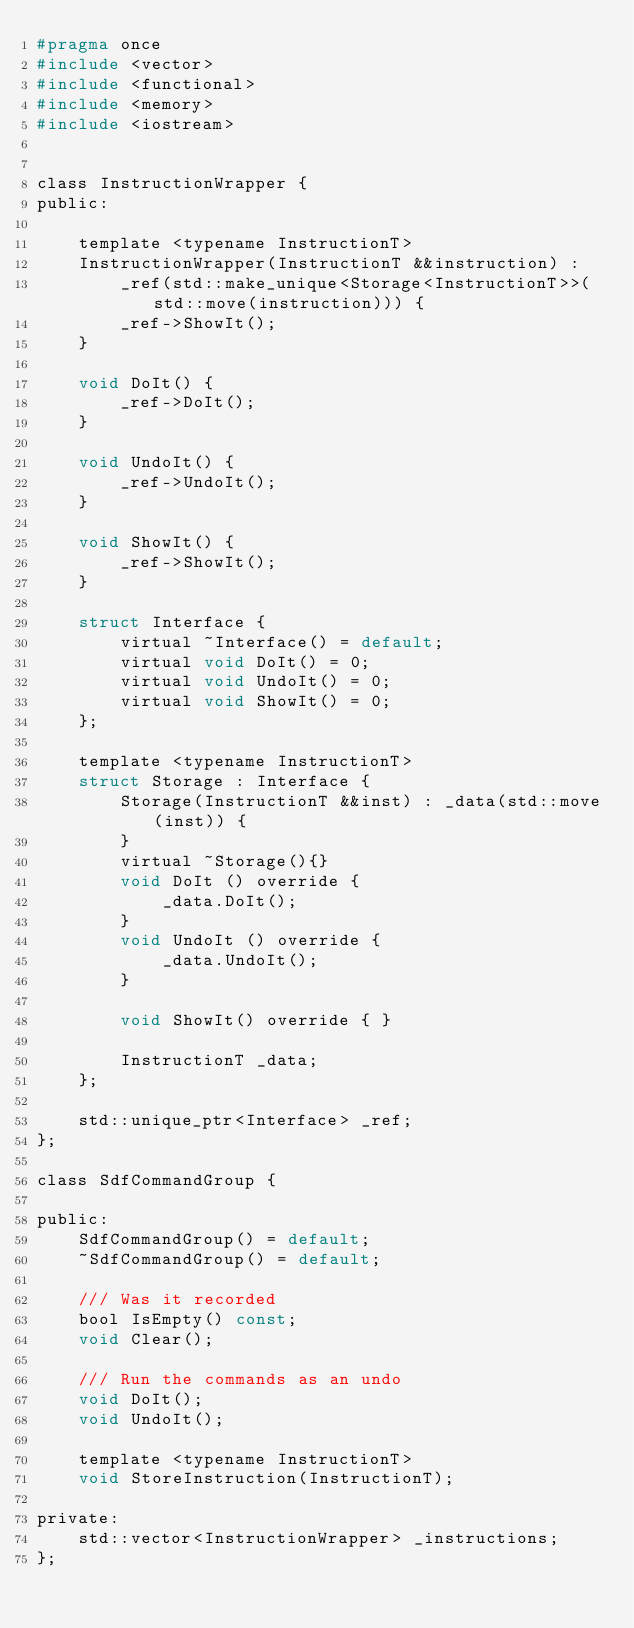<code> <loc_0><loc_0><loc_500><loc_500><_C_>#pragma once
#include <vector>
#include <functional>
#include <memory>
#include <iostream>


class InstructionWrapper {
public:

    template <typename InstructionT>
    InstructionWrapper(InstructionT &&instruction) :
        _ref(std::make_unique<Storage<InstructionT>>(std::move(instruction))) {
        _ref->ShowIt();
    }

    void DoIt() {
        _ref->DoIt();
    }

    void UndoIt() {
        _ref->UndoIt();
    }

    void ShowIt() {
        _ref->ShowIt();
    }

    struct Interface {
        virtual ~Interface() = default;
        virtual void DoIt() = 0;
        virtual void UndoIt() = 0;
        virtual void ShowIt() = 0;
    };

    template <typename InstructionT>
    struct Storage : Interface {
        Storage(InstructionT &&inst) : _data(std::move(inst)) {
        }
        virtual ~Storage(){}
        void DoIt () override {
            _data.DoIt();
        }
        void UndoIt () override {
            _data.UndoIt();
        }

        void ShowIt() override { }

        InstructionT _data;
    };

    std::unique_ptr<Interface> _ref;
};

class SdfCommandGroup {

public:
    SdfCommandGroup() = default;
    ~SdfCommandGroup() = default;

    /// Was it recorded
    bool IsEmpty() const;
    void Clear();

    /// Run the commands as an undo
    void DoIt();
    void UndoIt();

    template <typename InstructionT>
    void StoreInstruction(InstructionT);

private:
    std::vector<InstructionWrapper> _instructions;
};


</code> 